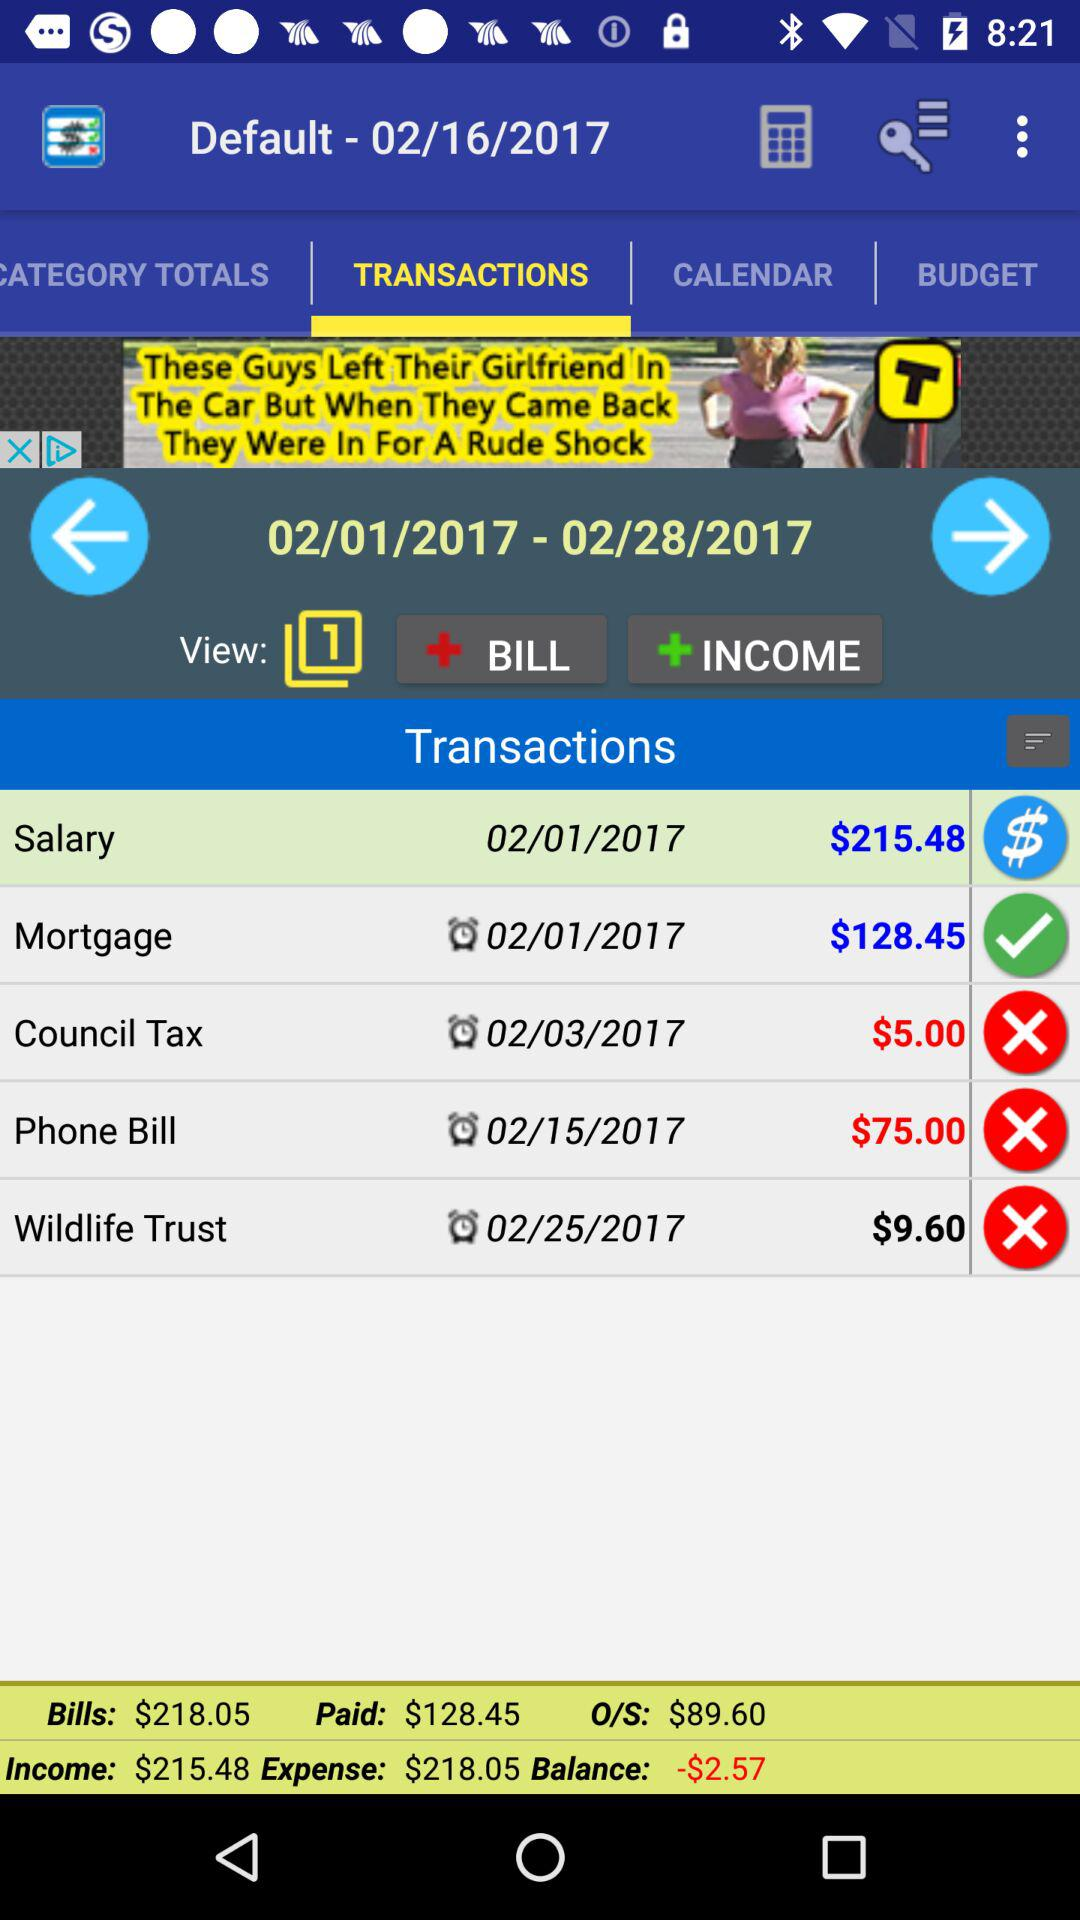What is the default date? The default date is February 16, 2017. 